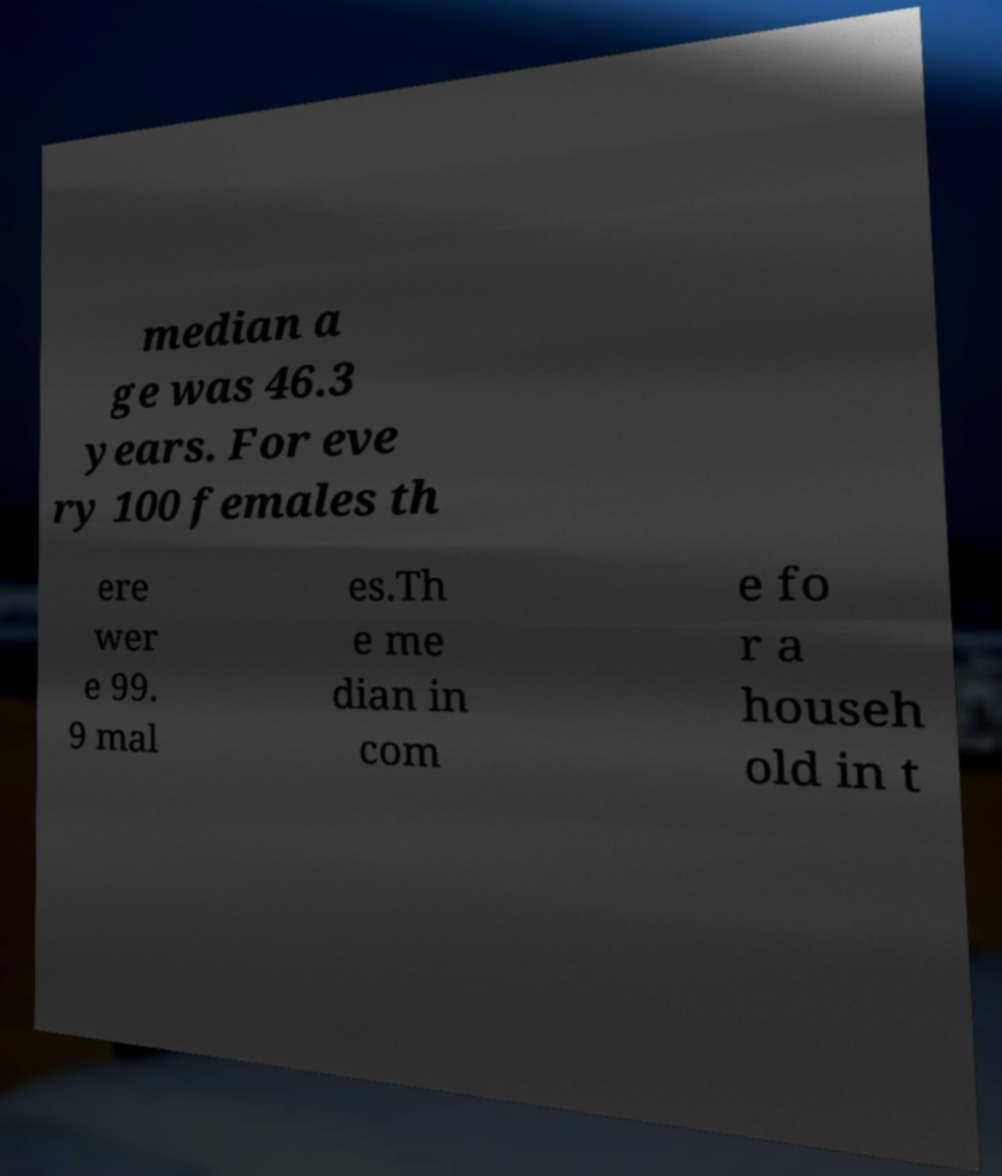For documentation purposes, I need the text within this image transcribed. Could you provide that? median a ge was 46.3 years. For eve ry 100 females th ere wer e 99. 9 mal es.Th e me dian in com e fo r a househ old in t 